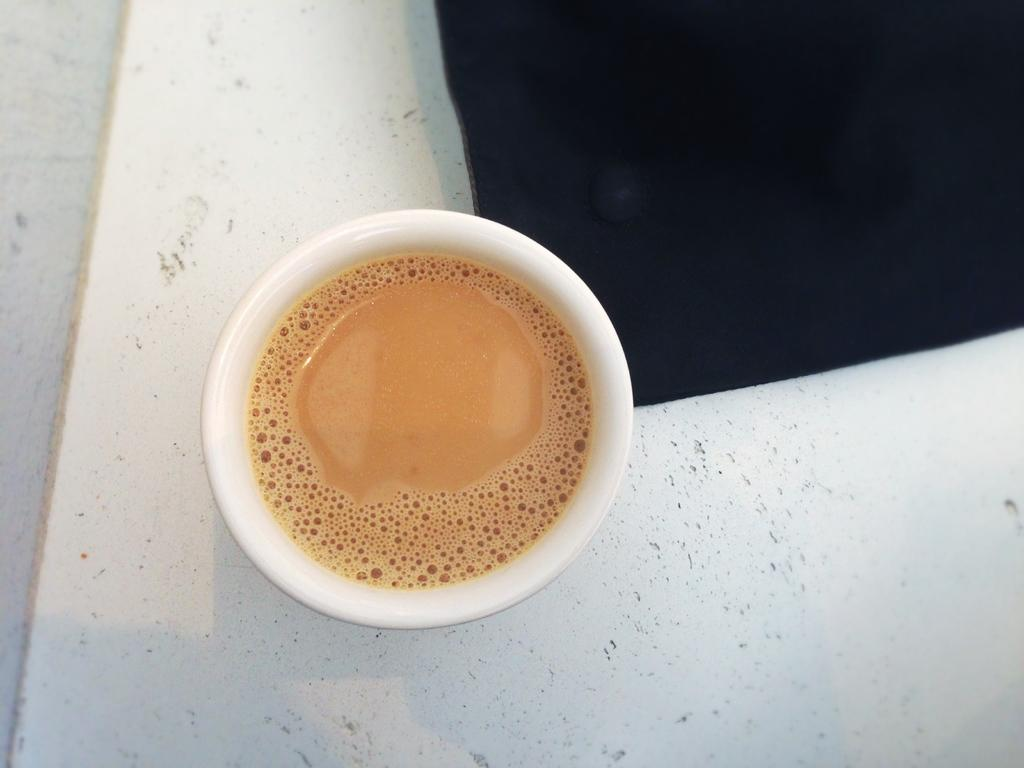What object is on the floor in the image? There is a tea cup on the floor in the image. What type of bat is flying around the tea cup in the image? There is no bat present in the image; it only features a tea cup on the floor. 